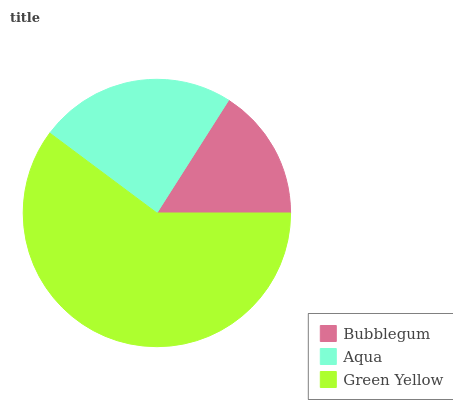Is Bubblegum the minimum?
Answer yes or no. Yes. Is Green Yellow the maximum?
Answer yes or no. Yes. Is Aqua the minimum?
Answer yes or no. No. Is Aqua the maximum?
Answer yes or no. No. Is Aqua greater than Bubblegum?
Answer yes or no. Yes. Is Bubblegum less than Aqua?
Answer yes or no. Yes. Is Bubblegum greater than Aqua?
Answer yes or no. No. Is Aqua less than Bubblegum?
Answer yes or no. No. Is Aqua the high median?
Answer yes or no. Yes. Is Aqua the low median?
Answer yes or no. Yes. Is Green Yellow the high median?
Answer yes or no. No. Is Green Yellow the low median?
Answer yes or no. No. 